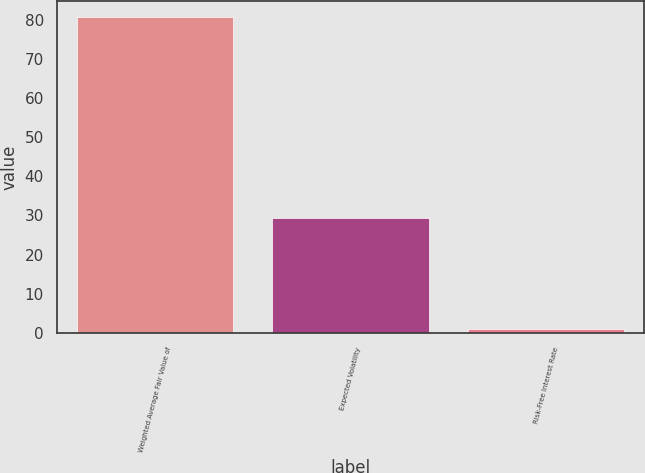Convert chart to OTSL. <chart><loc_0><loc_0><loc_500><loc_500><bar_chart><fcel>Weighted Average Fair Value of<fcel>Expected Volatility<fcel>Risk-Free Interest Rate<nl><fcel>80.64<fcel>29.35<fcel>1.07<nl></chart> 